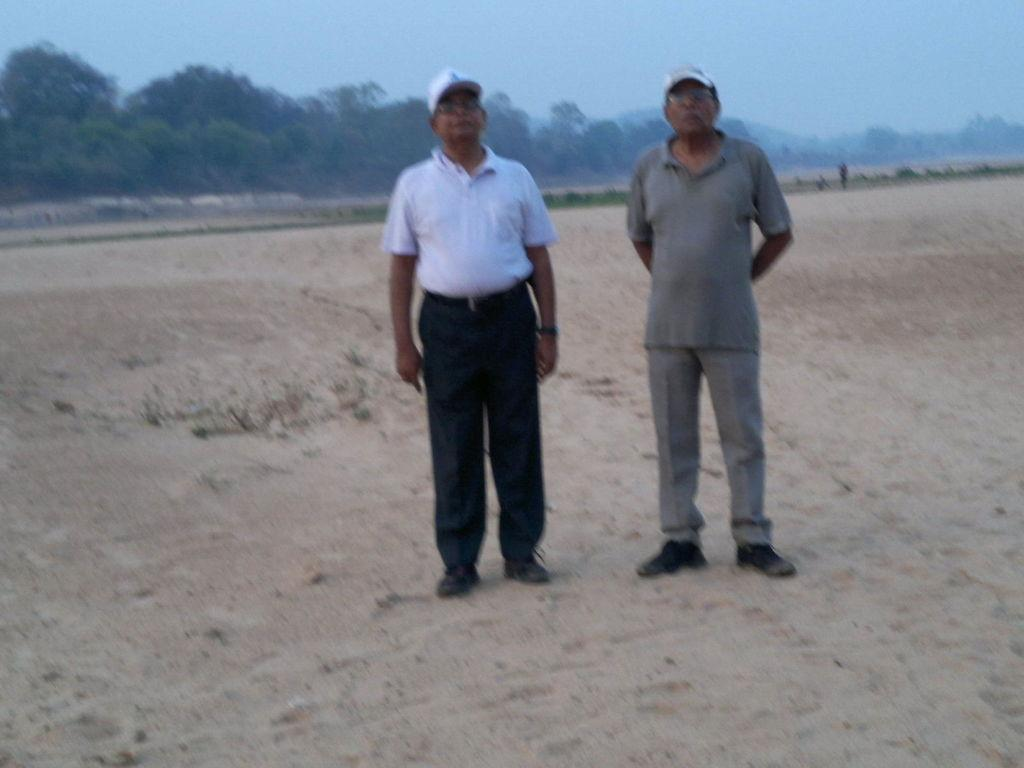How many people are in the image? There are two persons standing in the image. What can be seen in the background of the image? Trees and the sky are visible in the background of the image. What type of hat is the robin wearing in the image? There is no robin or hat present in the image. 